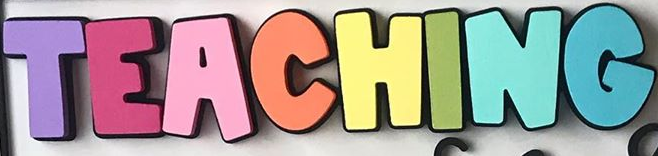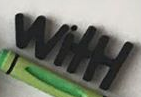What text is displayed in these images sequentially, separated by a semicolon? TEACHING; WitH 